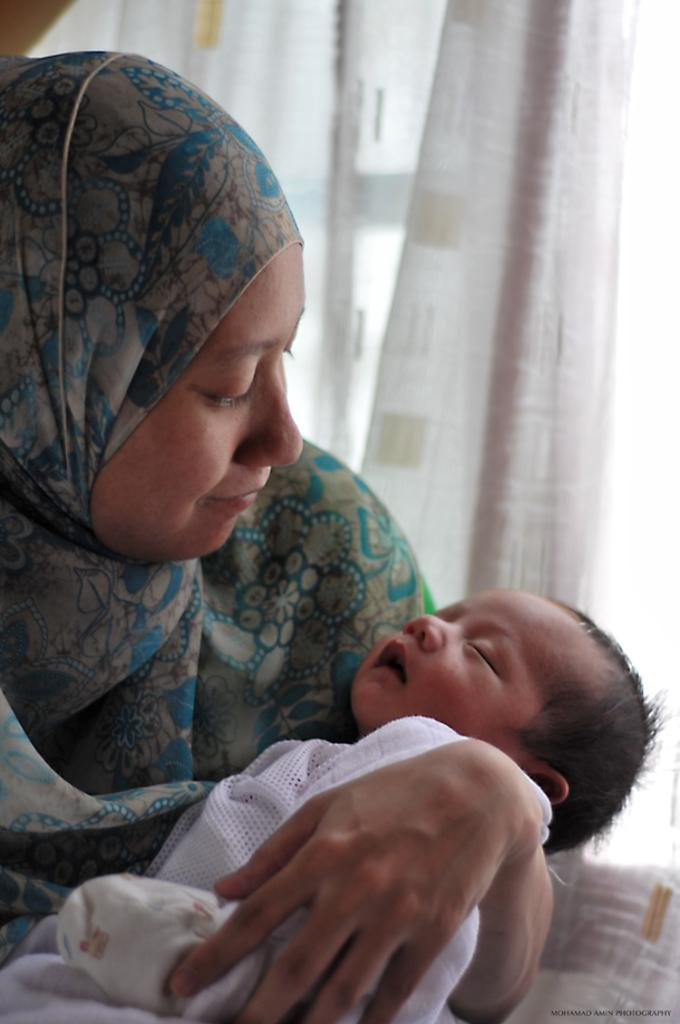What is the woman doing in the image? The woman is holding a baby in the image. What else can be seen in the background of the image? There is a curtain visible in the image. What type of worm can be seen crawling on the baby's hand in the image? There is no worm present in the image; the woman is holding a baby without any visible worms. 